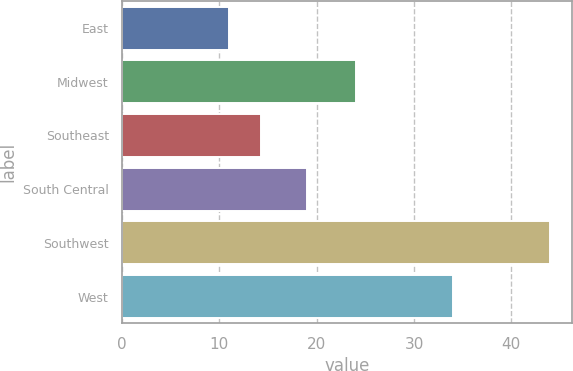Convert chart to OTSL. <chart><loc_0><loc_0><loc_500><loc_500><bar_chart><fcel>East<fcel>Midwest<fcel>Southeast<fcel>South Central<fcel>Southwest<fcel>West<nl><fcel>11<fcel>24<fcel>14.3<fcel>19<fcel>44<fcel>34<nl></chart> 